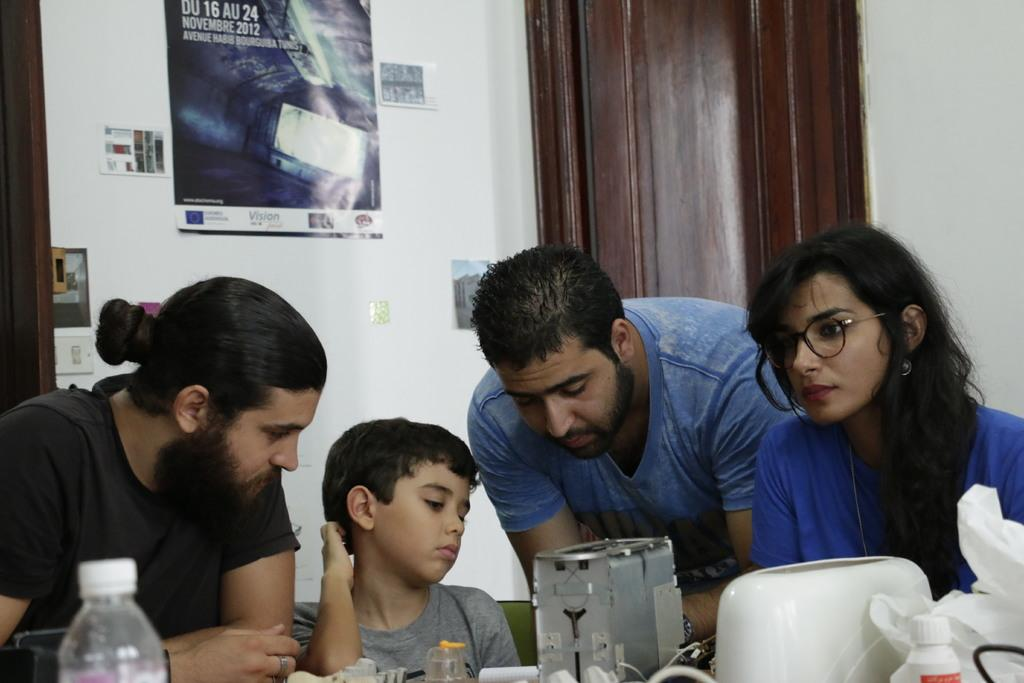How many people can be seen in the image? There are a few people in the image. What is located at the bottom of the image? There are objects at the bottom of the image. What is on the wall in the image? There is a wall with posters in the image. What material is visible in the image? There is wood visible in the image. What type of containers can be seen in the image? There are a few bottles in the image. What type of music can be heard playing in the image? There is no indication of music or any sound in the image, so it cannot be determined from the image. 